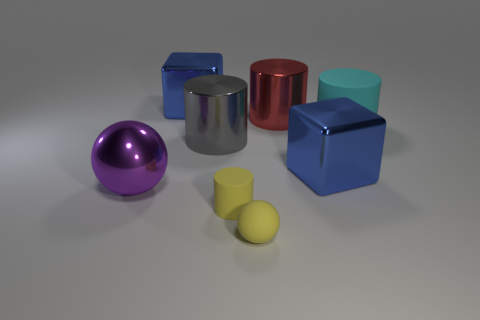Are there any other things that have the same shape as the big red thing?
Your answer should be compact. Yes. Are there an equal number of blue metallic objects to the right of the big rubber thing and cyan rubber objects?
Your answer should be compact. No. There is a metallic sphere; does it have the same color as the matte thing that is behind the large purple object?
Offer a terse response. No. What color is the metal thing that is both behind the large cyan rubber cylinder and left of the small matte cylinder?
Keep it short and to the point. Blue. How many rubber balls are behind the rubber object behind the large ball?
Give a very brief answer. 0. Is there a gray shiny object of the same shape as the cyan rubber thing?
Offer a terse response. Yes. There is a blue thing left of the big gray cylinder; is it the same shape as the blue shiny object that is on the right side of the yellow rubber sphere?
Make the answer very short. Yes. How many things are large brown metallic spheres or matte cylinders?
Provide a short and direct response. 2. There is another thing that is the same shape as the big purple metal object; what size is it?
Your response must be concise. Small. Are there more big blue things behind the small yellow cylinder than tiny metallic blocks?
Give a very brief answer. Yes. 